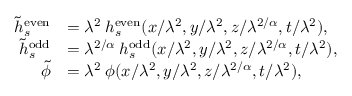<formula> <loc_0><loc_0><loc_500><loc_500>\begin{array} { r l } { \tilde { h } _ { s } ^ { e v e n } } & { = \lambda ^ { 2 } \, h _ { s } ^ { e v e n } ( x / \lambda ^ { 2 } , y / \lambda ^ { 2 } , z / \lambda ^ { 2 / \alpha } , t / \lambda ^ { 2 } ) , } \\ { \tilde { h } _ { s } ^ { o d d } } & { = \lambda ^ { 2 / \alpha } \, h _ { s } ^ { o d d } ( x / \lambda ^ { 2 } , y / \lambda ^ { 2 } , z / \lambda ^ { 2 / \alpha } , t / \lambda ^ { 2 } ) , } \\ { \tilde { \phi } } & { = \lambda ^ { 2 } \, \phi ( x / \lambda ^ { 2 } , y / \lambda ^ { 2 } , z / \lambda ^ { 2 / \alpha } , t / \lambda ^ { 2 } ) , } \end{array}</formula> 